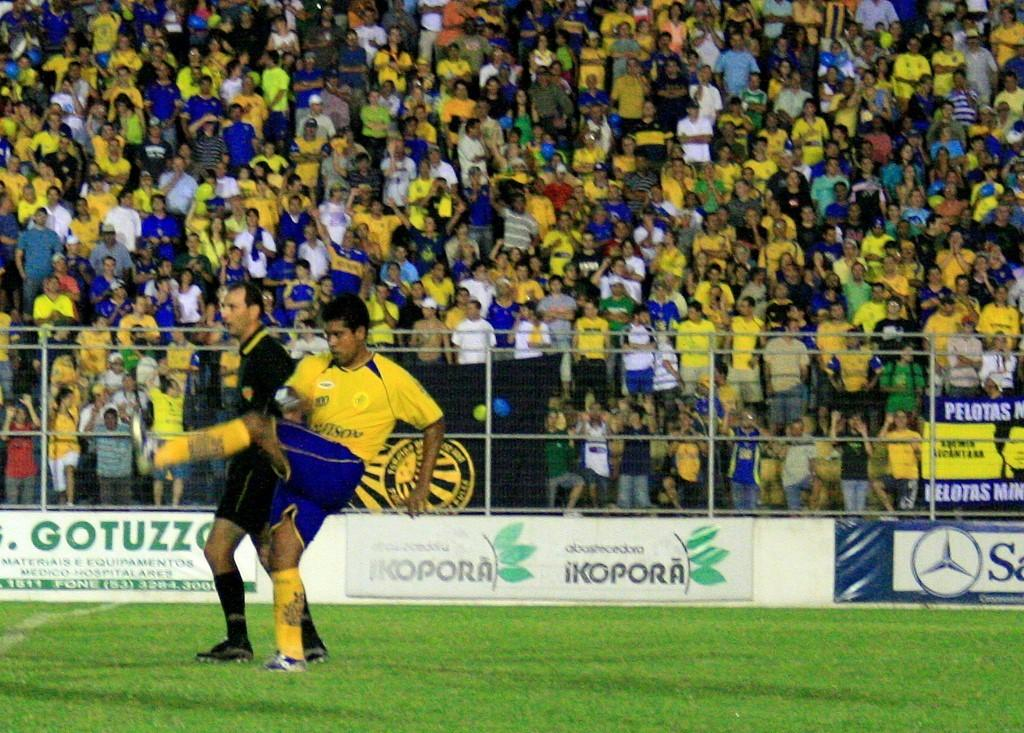<image>
Render a clear and concise summary of the photo. Person kicking a ball on a field with the ad for "Gotuzza" in the back. 